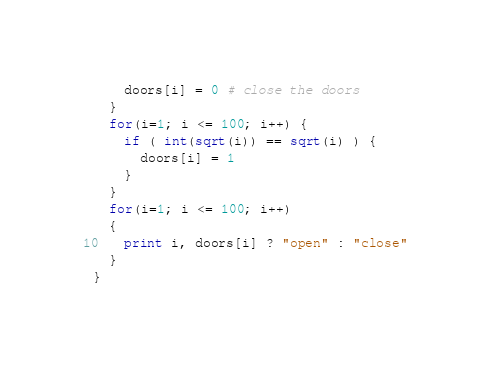Convert code to text. <code><loc_0><loc_0><loc_500><loc_500><_Awk_>    doors[i] = 0 # close the doors
  }
  for(i=1; i <= 100; i++) {
    if ( int(sqrt(i)) == sqrt(i) ) {
      doors[i] = 1
    }
  }
  for(i=1; i <= 100; i++)
  {
    print i, doors[i] ? "open" : "close"
  }
}
</code> 